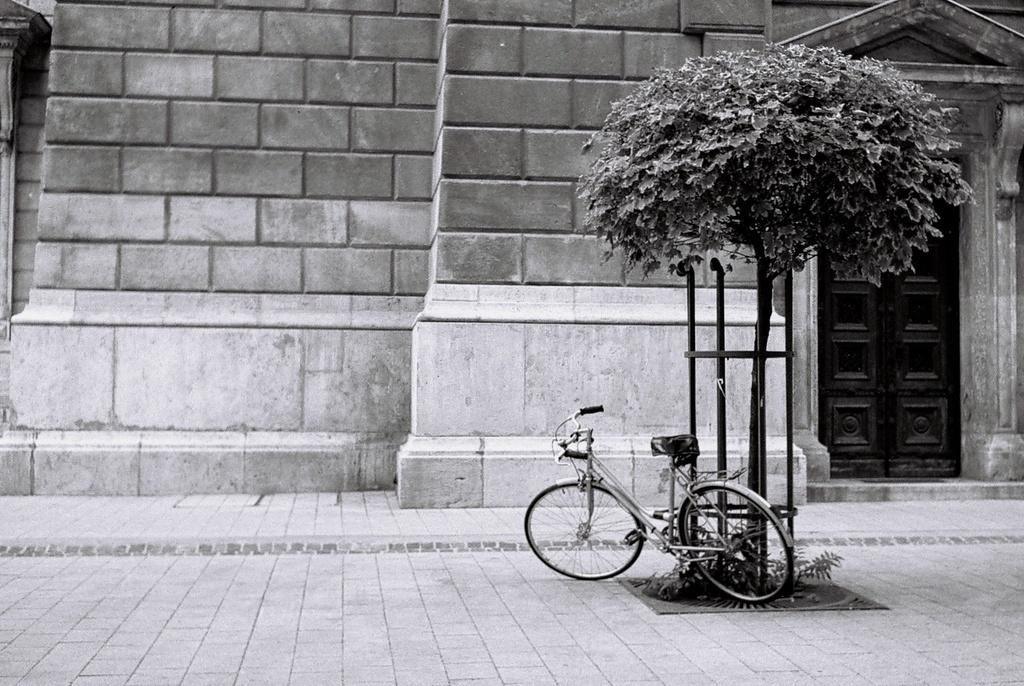What is the color scheme of the image? The image is in black and white. What can be seen in the image? There is a building in the image. What feature does the building have? The building has a door. What is located in front of the building? There is a tree and a bicycle in front of the building. What invention is being credited to the person holding the pen in the image? There is no person holding a pen in the image, and no invention is being credited. 